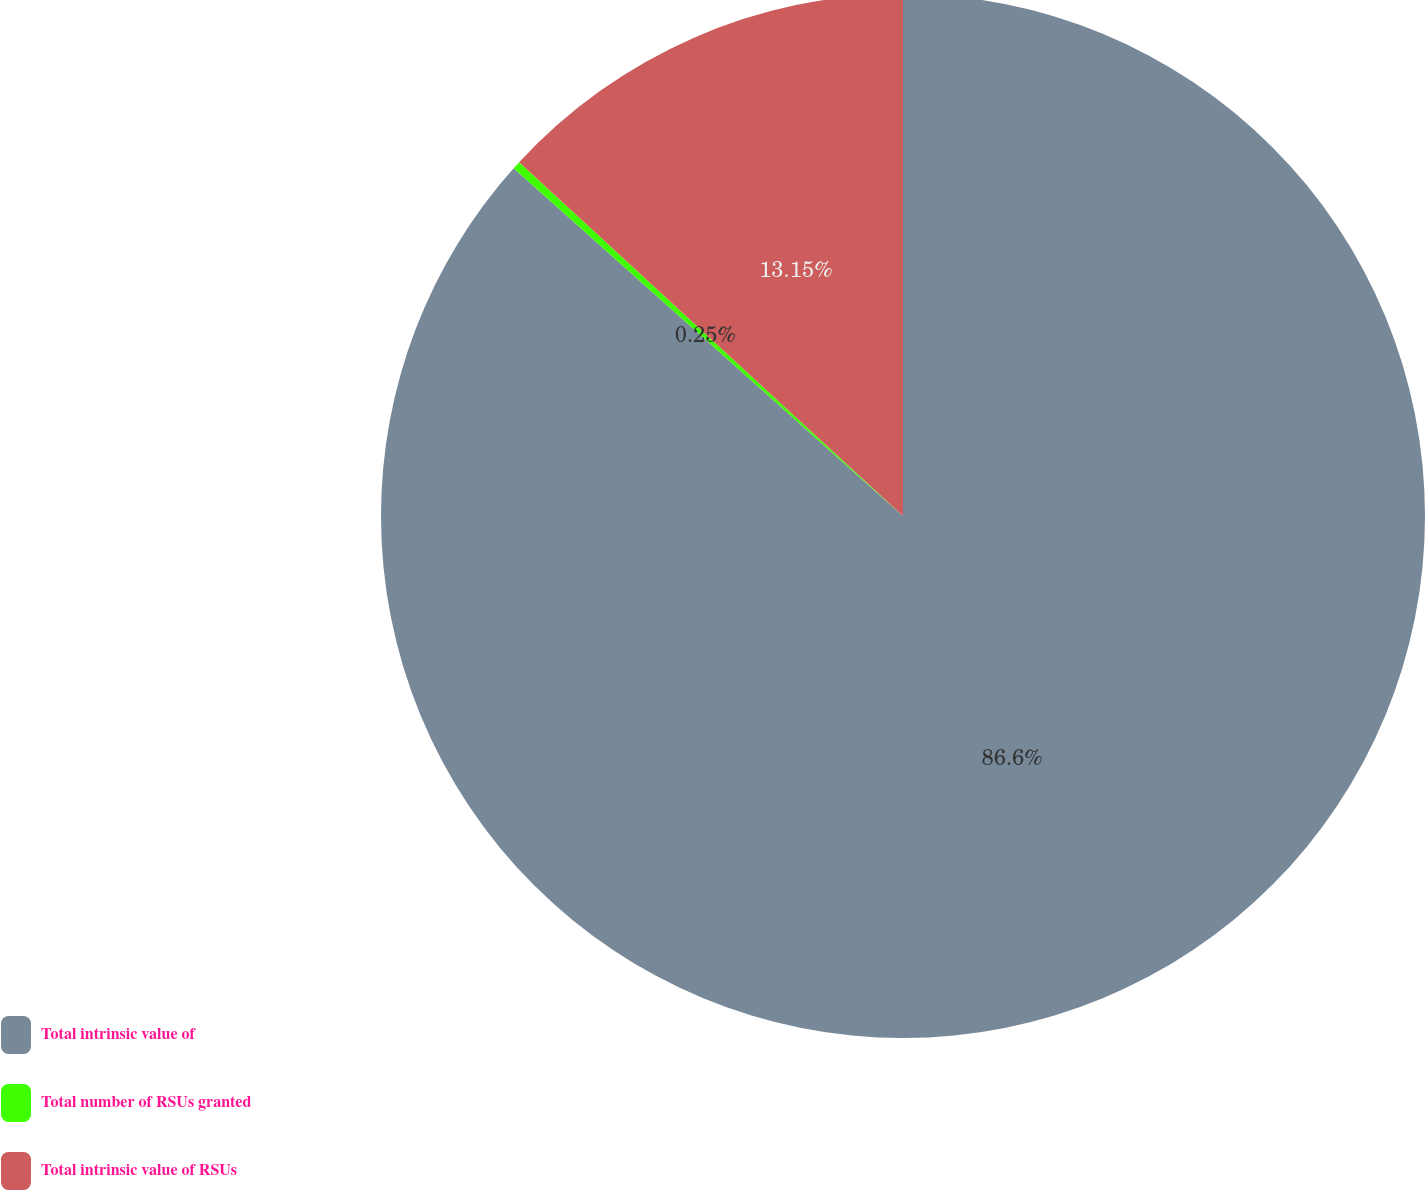<chart> <loc_0><loc_0><loc_500><loc_500><pie_chart><fcel>Total intrinsic value of<fcel>Total number of RSUs granted<fcel>Total intrinsic value of RSUs<nl><fcel>86.61%<fcel>0.25%<fcel>13.15%<nl></chart> 